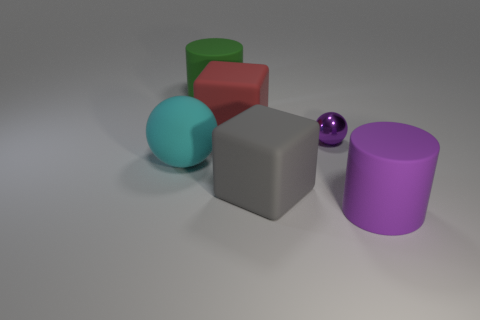Is there any other thing that is made of the same material as the small ball?
Ensure brevity in your answer.  No. Are there any other things that have the same size as the purple metal thing?
Your response must be concise. No. Is there anything else that is the same color as the matte ball?
Your answer should be compact. No. What number of tiny purple things are there?
Provide a succinct answer. 1. What is the material of the large cylinder behind the cylinder in front of the green thing?
Your answer should be very brief. Rubber. There is a big rubber thing on the left side of the rubber cylinder that is behind the large thing that is left of the big green object; what is its color?
Provide a succinct answer. Cyan. Do the rubber ball and the tiny metallic thing have the same color?
Keep it short and to the point. No. What number of rubber spheres have the same size as the purple shiny ball?
Offer a very short reply. 0. Are there more matte objects right of the big gray matte block than metallic balls behind the purple metal sphere?
Ensure brevity in your answer.  Yes. The cube that is behind the large block right of the large red matte object is what color?
Offer a terse response. Red. 